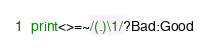<code> <loc_0><loc_0><loc_500><loc_500><_Perl_>print<>=~/(.)\1/?Bad:Good</code> 